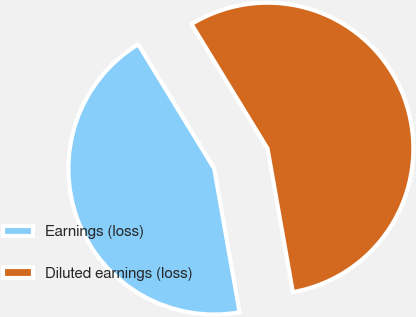<chart> <loc_0><loc_0><loc_500><loc_500><pie_chart><fcel>Earnings (loss)<fcel>Diluted earnings (loss)<nl><fcel>44.05%<fcel>55.95%<nl></chart> 